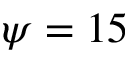Convert formula to latex. <formula><loc_0><loc_0><loc_500><loc_500>\psi = 1 5</formula> 